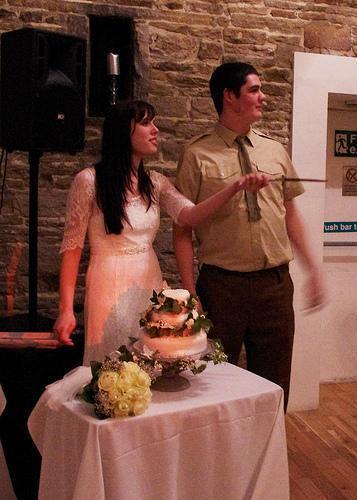How many people are in this picture?
Give a very brief answer. 2. 